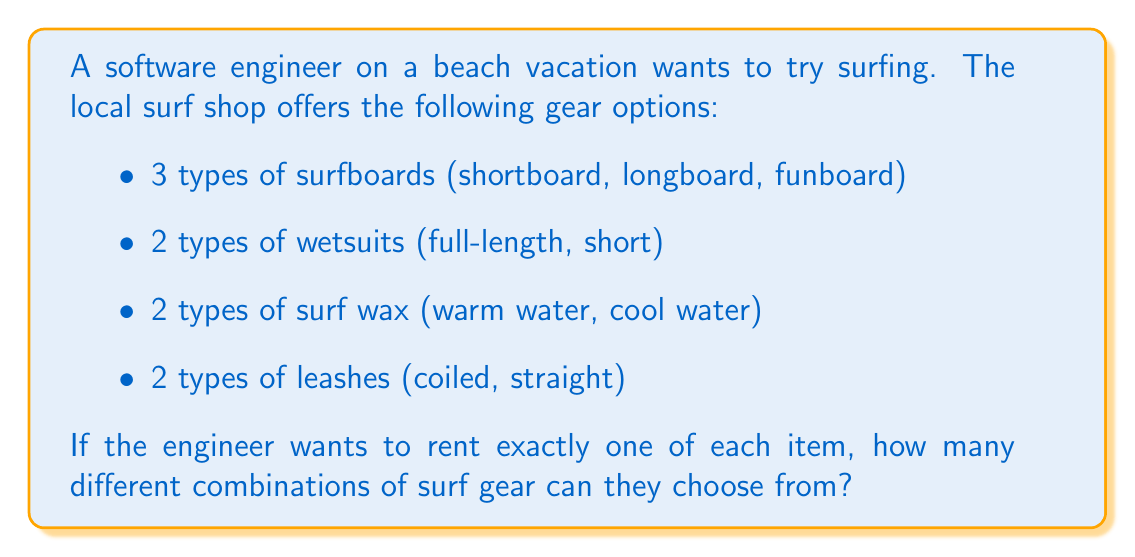Can you solve this math problem? To solve this problem, we'll use the multiplication principle of counting. This principle states that if we have a sequence of independent choices, where there are:
- $m_1$ ways of making the first choice
- $m_2$ ways of making the second choice
- ...
- $m_n$ ways of making the nth choice

Then the total number of ways to make all these choices is the product:

$$ m_1 \times m_2 \times ... \times m_n $$

In our case:
1. There are 3 choices for the surfboard
2. There are 2 choices for the wetsuit
3. There are 2 choices for the surf wax
4. There are 2 choices for the leash

Therefore, the total number of combinations is:

$$ 3 \times 2 \times 2 \times 2 = 24 $$

We can also think of this as creating a tree diagram where each level represents a choice:

[asy]
unitsize(1cm);

void drawBranch(pair start, pair end) {
  draw(start--end);
}

void drawNode(pair p) {
  fill(p, circle(p, 0.1), white);
  draw(circle(p, 0.1));
}

pair root = (0,0);
drawNode(root);

for (int i = 0; i < 3; ++i) {
  pair p1 = root + (2, -1-i);
  drawBranch(root, p1);
  drawNode(p1);
  
  for (int j = 0; j < 2; ++j) {
    pair p2 = p1 + (2, -0.5-j);
    drawBranch(p1, p2);
    drawNode(p2);
    
    for (int k = 0; k < 2; ++k) {
      pair p3 = p2 + (2, -0.25-0.5*k);
      drawBranch(p2, p3);
      drawNode(p3);
      
      for (int l = 0; l < 2; ++l) {
        pair p4 = p3 + (2, -0.125-0.25*l);
        drawBranch(p3, p4);
        drawNode(p4);
      }
    }
  }
}

label("Surfboard", (-1,0));
label("Wetsuit", (1,0));
label("Wax", (3,0));
label("Leash", (5,0));
label("24 outcomes", (8,-2));
[/asy]

Each path from the root to a leaf represents a unique combination, and there are 24 such paths.
Answer: $24$ combinations 